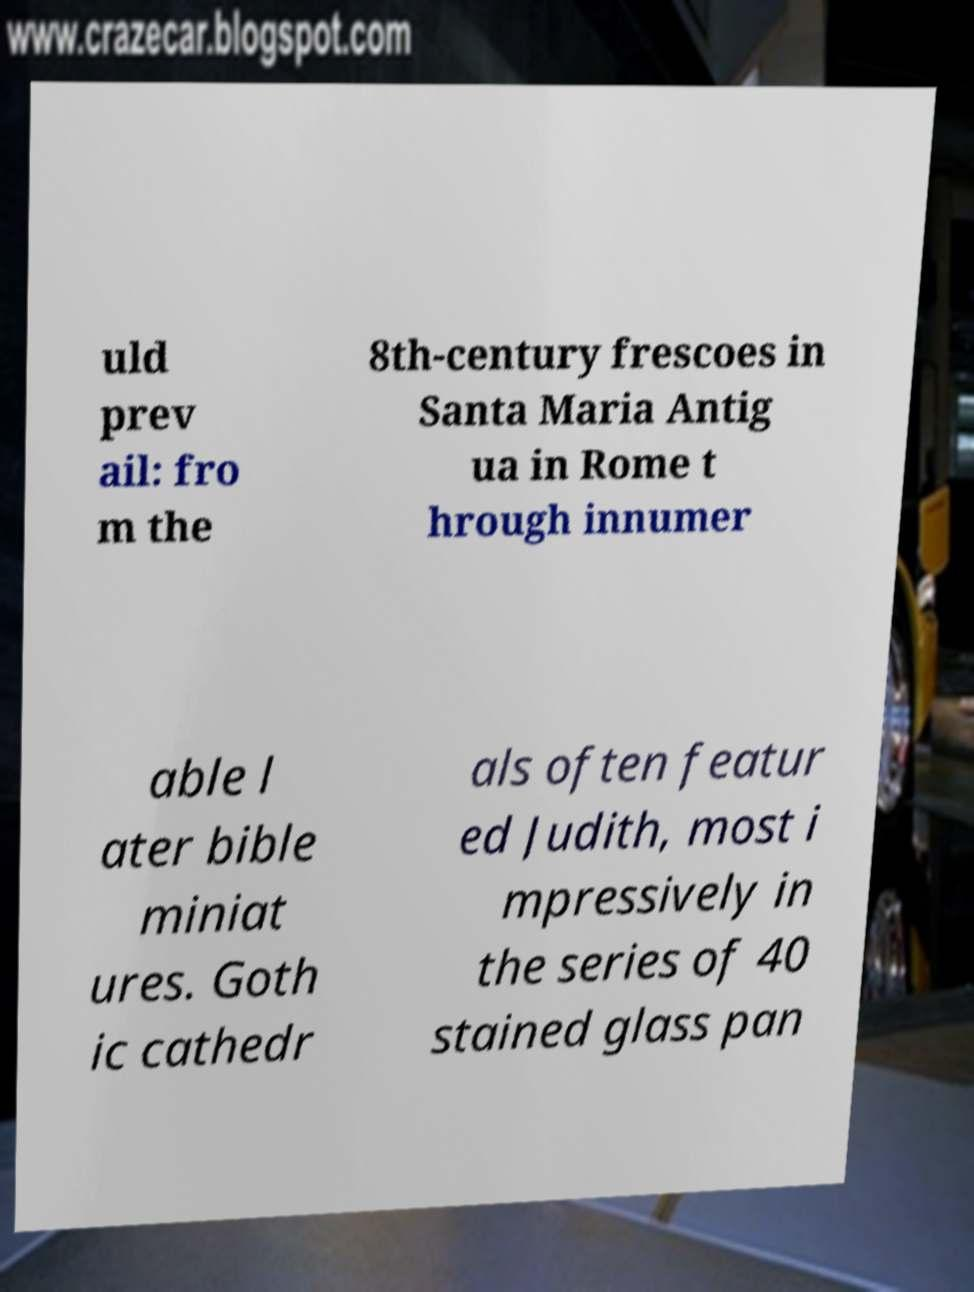Please identify and transcribe the text found in this image. uld prev ail: fro m the 8th-century frescoes in Santa Maria Antig ua in Rome t hrough innumer able l ater bible miniat ures. Goth ic cathedr als often featur ed Judith, most i mpressively in the series of 40 stained glass pan 